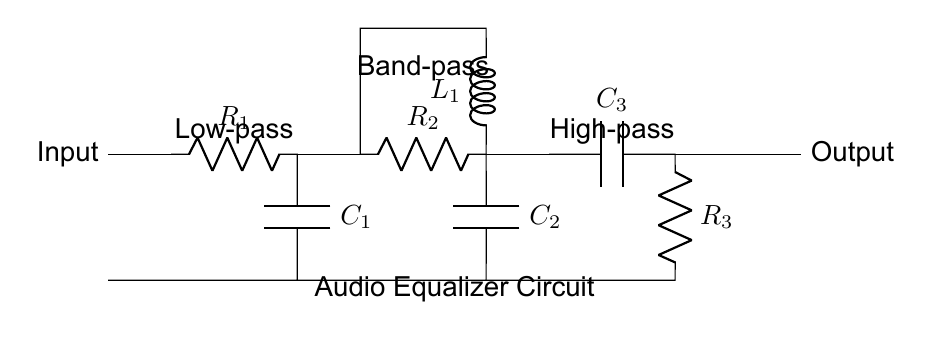What is the main function of this circuit? The main function of this circuit is to adjust the audio frequencies sent to the speakers, enhancing the overall sound quality for listeners. It achieves this through low-pass, band-pass, and high-pass filters which target different frequency ranges.
Answer: Audio equalizer What type of filter is connected at the beginning of the circuit? The first component after the input is a resistor followed by a capacitor, which indicates that the section is a low-pass filter, allowing low frequencies to pass while attenuating higher frequencies.
Answer: Low-pass How many components are in the band-pass filter section? The band-pass filter section contains a resistor, a capacitor, and an inductor, making a total of three components that work together to allow a specific range of frequencies to pass while blocking others.
Answer: Three What component is directly connected after the band-pass filter? After the band-pass filter, the next component is a capacitor, which is part of the high-pass filter section in the circuit, allowing high frequencies to pass while blocking lower frequencies.
Answer: Capacitor Which frequency range does the high-pass filter affect? The high-pass filter affects high frequencies, meaning it allows frequencies above a certain cutoff point to pass while attenuating frequencies below that cutoff.
Answer: High frequencies What is the overall arrangement of this filter circuit? The overall arrangement follows a sequence where the audio input passes first through a low-pass filter, followed by a band-pass filter, and finally a high-pass filter before reaching the output, ensuring various frequencies can be adjusted effectively.
Answer: Sequential 